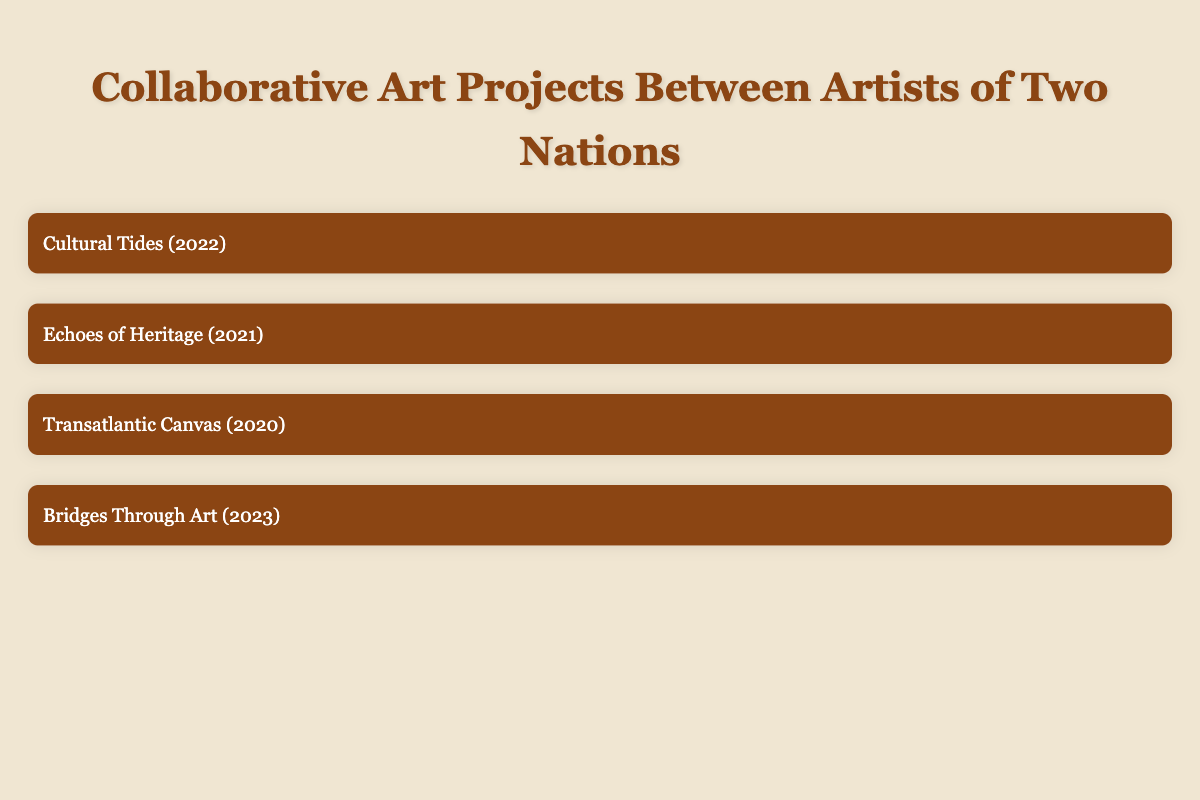What are the themes of the project "Cultural Tides"? The themes are listed under the project "Cultural Tides" in the table. They include "Cultural exchange," "Political activism," and "Social justice."
Answer: The themes are Cultural exchange, Political activism, Social justice Which two artists collaborated in the project "Echoes of Heritage"? The table indicates that Yoko Ono from Japan and Kara Walker from the United States collaborated on this project.
Answer: Yoko Ono and Kara Walker Is "Transatlantic Canvas" a performance art project? The medium for "Transatlantic Canvas" is noted as "Sculpture and installation" in the table, which means it is not a performance art project.
Answer: No How many exhibition locations are there for the project "Bridges Through Art"? The exhibition locations for "Bridges Through Art" are listed in the table, which shows two locations: "Los Angeles, USA" and "Bristol, UK." Therefore, there are two exhibition locations.
Answer: 2 Which artist participated in the most recent project listed in the table and what is the year of that project? The most recent project listed is "Bridges Through Art," which took place in 2023. One of the artists, Banksy, is from the United Kingdom.
Answer: Banksy, 2023 What is the average year of the collaborative projects listed in the table? The years of the projects are 2022, 2021, 2020, and 2023. Adding these together gives 2022 + 2021 + 2020 + 2023 = 8086, which divided by 4 results in an average year of 2021.5, rounding gives 2022 as a concise interpretation.
Answer: 2022 Did any project feature artists from Japan? Yes, "Echoes of Heritage" features Yoko Ono, who is from Japan. This fact can be verified by examining the artists listed under that project in the table.
Answer: Yes How many nations are represented by the artists in the projects? We can identify the countries involved from the artists listed in the four projects: China, United States, Japan, United Kingdom, Cuba. Counting distinct countries gives a total of five different nations.
Answer: 5 What common theme is present in both "Cultural Tides" and "Bridges Through Art"? By reviewing the themes of both projects, "Cultural Tides" discusses "Cultural exchange" and "Social justice," while "Bridges Through Art" addresses "Community engagement," "Unity," and "Diversity." They both discuss themes related to community and societal values, notably "Community engagement" can tie broadly to "Cultural exchange."
Answer: Community engagement, Cultural exchange 